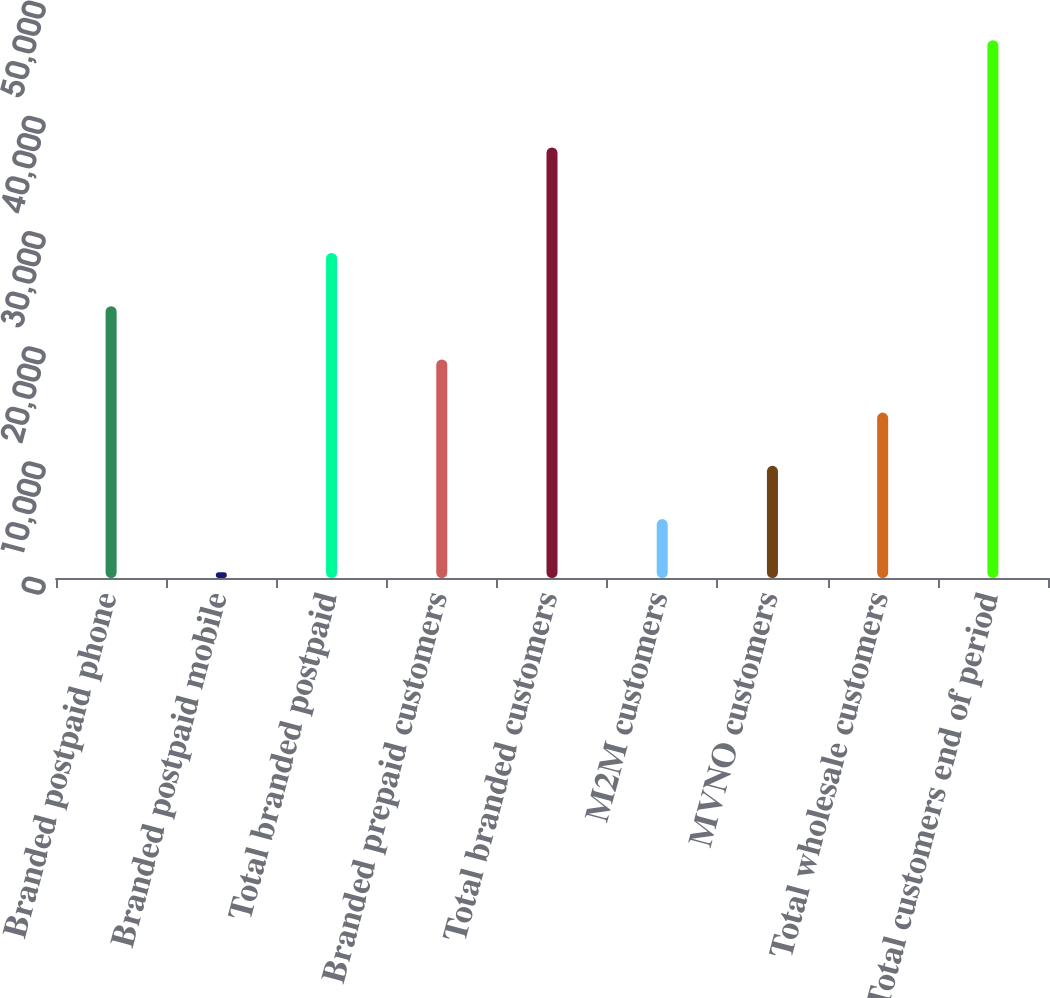Convert chart to OTSL. <chart><loc_0><loc_0><loc_500><loc_500><bar_chart><fcel>Branded postpaid phone<fcel>Branded postpaid mobile<fcel>Total branded postpaid<fcel>Branded prepaid customers<fcel>Total branded customers<fcel>M2M customers<fcel>MVNO customers<fcel>Total wholesale customers<fcel>Total customers end of period<nl><fcel>23593<fcel>502<fcel>28211.2<fcel>18974.8<fcel>37371<fcel>5120.2<fcel>9738.4<fcel>14356.6<fcel>46684<nl></chart> 